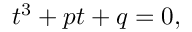<formula> <loc_0><loc_0><loc_500><loc_500>t ^ { 3 } + p t + q = 0 ,</formula> 